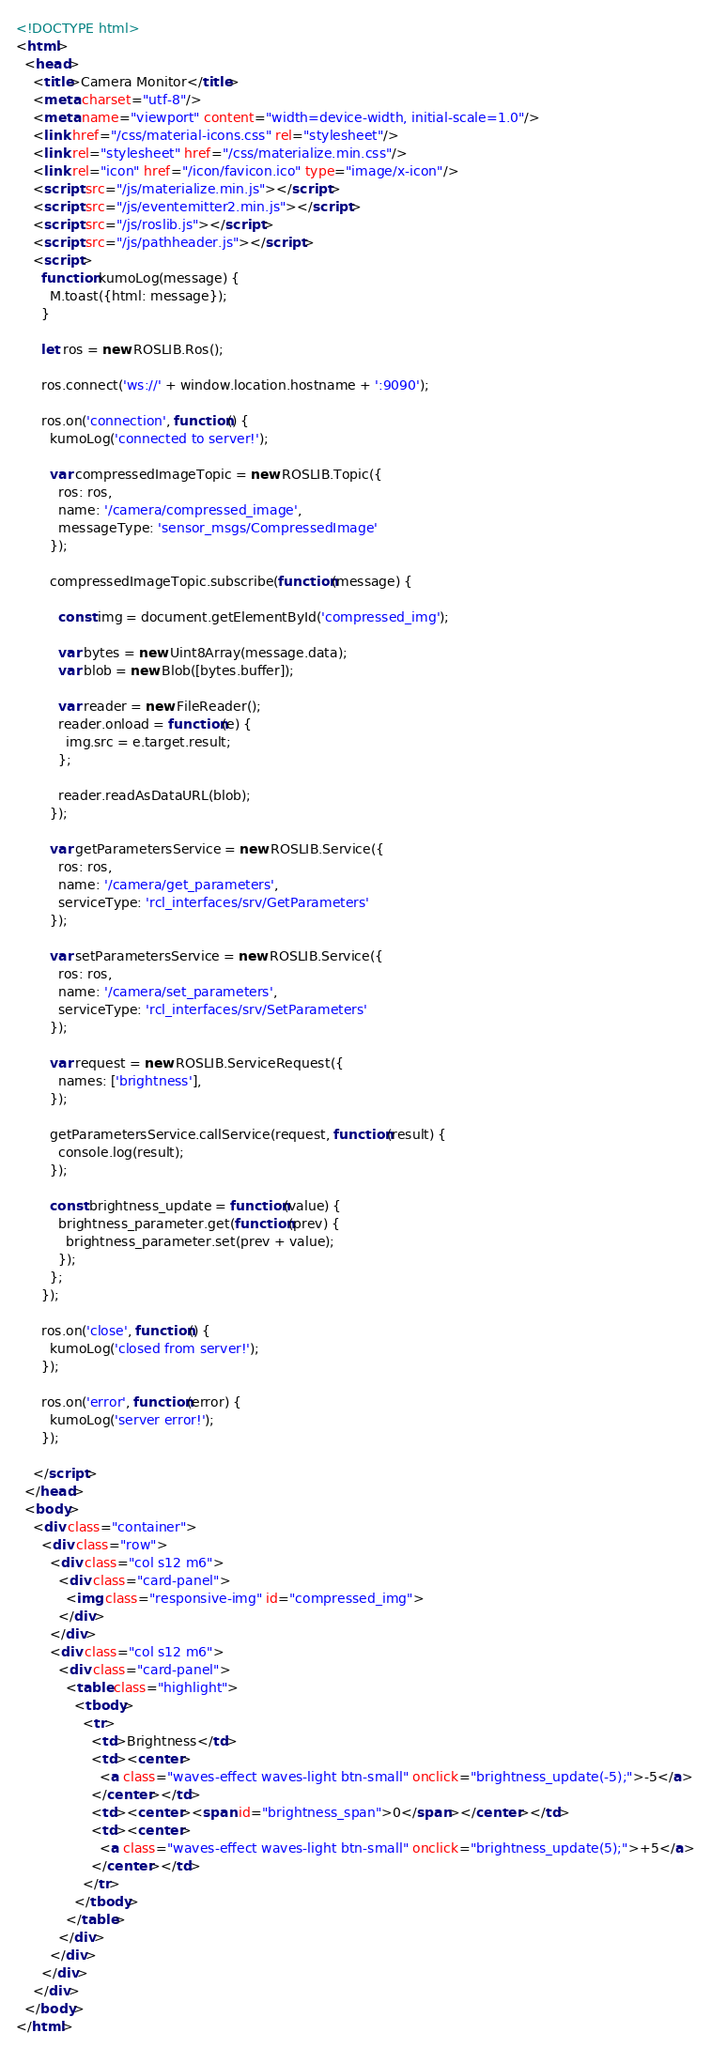Convert code to text. <code><loc_0><loc_0><loc_500><loc_500><_HTML_><!DOCTYPE html>
<html>
  <head>
    <title>Camera Monitor</title>
    <meta charset="utf-8"/>
    <meta name="viewport" content="width=device-width, initial-scale=1.0"/>
    <link href="/css/material-icons.css" rel="stylesheet"/>
    <link rel="stylesheet" href="/css/materialize.min.css"/>
    <link rel="icon" href="/icon/favicon.ico" type="image/x-icon"/>
    <script src="/js/materialize.min.js"></script>
    <script src="/js/eventemitter2.min.js"></script>
    <script src="/js/roslib.js"></script>
    <script src="/js/pathheader.js"></script>
    <script>
      function kumoLog(message) {
        M.toast({html: message});
      }

      let ros = new ROSLIB.Ros();

      ros.connect('ws://' + window.location.hostname + ':9090');

      ros.on('connection', function() {
        kumoLog('connected to server!');

        var compressedImageTopic = new ROSLIB.Topic({
          ros: ros,
          name: '/camera/compressed_image',
          messageType: 'sensor_msgs/CompressedImage'
        });

        compressedImageTopic.subscribe(function(message) {

          const img = document.getElementById('compressed_img');

          var bytes = new Uint8Array(message.data);
          var blob = new Blob([bytes.buffer]);

          var reader = new FileReader();
          reader.onload = function(e) {
            img.src = e.target.result;
          };

          reader.readAsDataURL(blob);
        });

        var getParametersService = new ROSLIB.Service({
          ros: ros,
          name: '/camera/get_parameters',
          serviceType: 'rcl_interfaces/srv/GetParameters'
        });

        var setParametersService = new ROSLIB.Service({
          ros: ros,
          name: '/camera/set_parameters',
          serviceType: 'rcl_interfaces/srv/SetParameters'
        });

        var request = new ROSLIB.ServiceRequest({
          names: ['brightness'],
        });

        getParametersService.callService(request, function(result) {
          console.log(result);
        });

        const brightness_update = function(value) {
          brightness_parameter.get(function(prev) {
            brightness_parameter.set(prev + value);
          });
        };
      });

      ros.on('close', function() {
        kumoLog('closed from server!');
      });

      ros.on('error', function(error) {
        kumoLog('server error!');
      });

    </script>
  </head>
  <body>
    <div class="container">
      <div class="row">
        <div class="col s12 m6">
          <div class="card-panel">
            <img class="responsive-img" id="compressed_img">
          </div>
        </div>
        <div class="col s12 m6">
          <div class="card-panel">
            <table class="highlight">
              <tbody>
                <tr>
                  <td>Brightness</td>
                  <td><center>
                    <a class="waves-effect waves-light btn-small" onclick="brightness_update(-5);">-5</a>
                  </center></td>
                  <td><center><span id="brightness_span">0</span></center></td>
                  <td><center>
                    <a class="waves-effect waves-light btn-small" onclick="brightness_update(5);">+5</a>
                  </center></td>
                </tr>
              </tbody>
            </table>
          </div>
        </div>
      </div>
    </div>
  </body>
</html>
</code> 